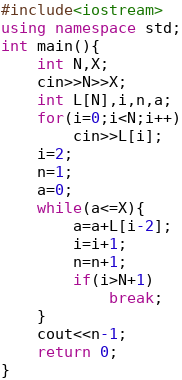<code> <loc_0><loc_0><loc_500><loc_500><_C++_>#include<iostream>
using namespace std;
int main(){
    int N,X;
    cin>>N>>X;
    int L[N],i,n,a;
    for(i=0;i<N;i++)
        cin>>L[i];
    i=2;
    n=1;
    a=0;
    while(a<=X){
        a=a+L[i-2];
        i=i+1;
        n=n+1;
        if(i>N+1)
            break;
    }
    cout<<n-1;
    return 0;
}</code> 